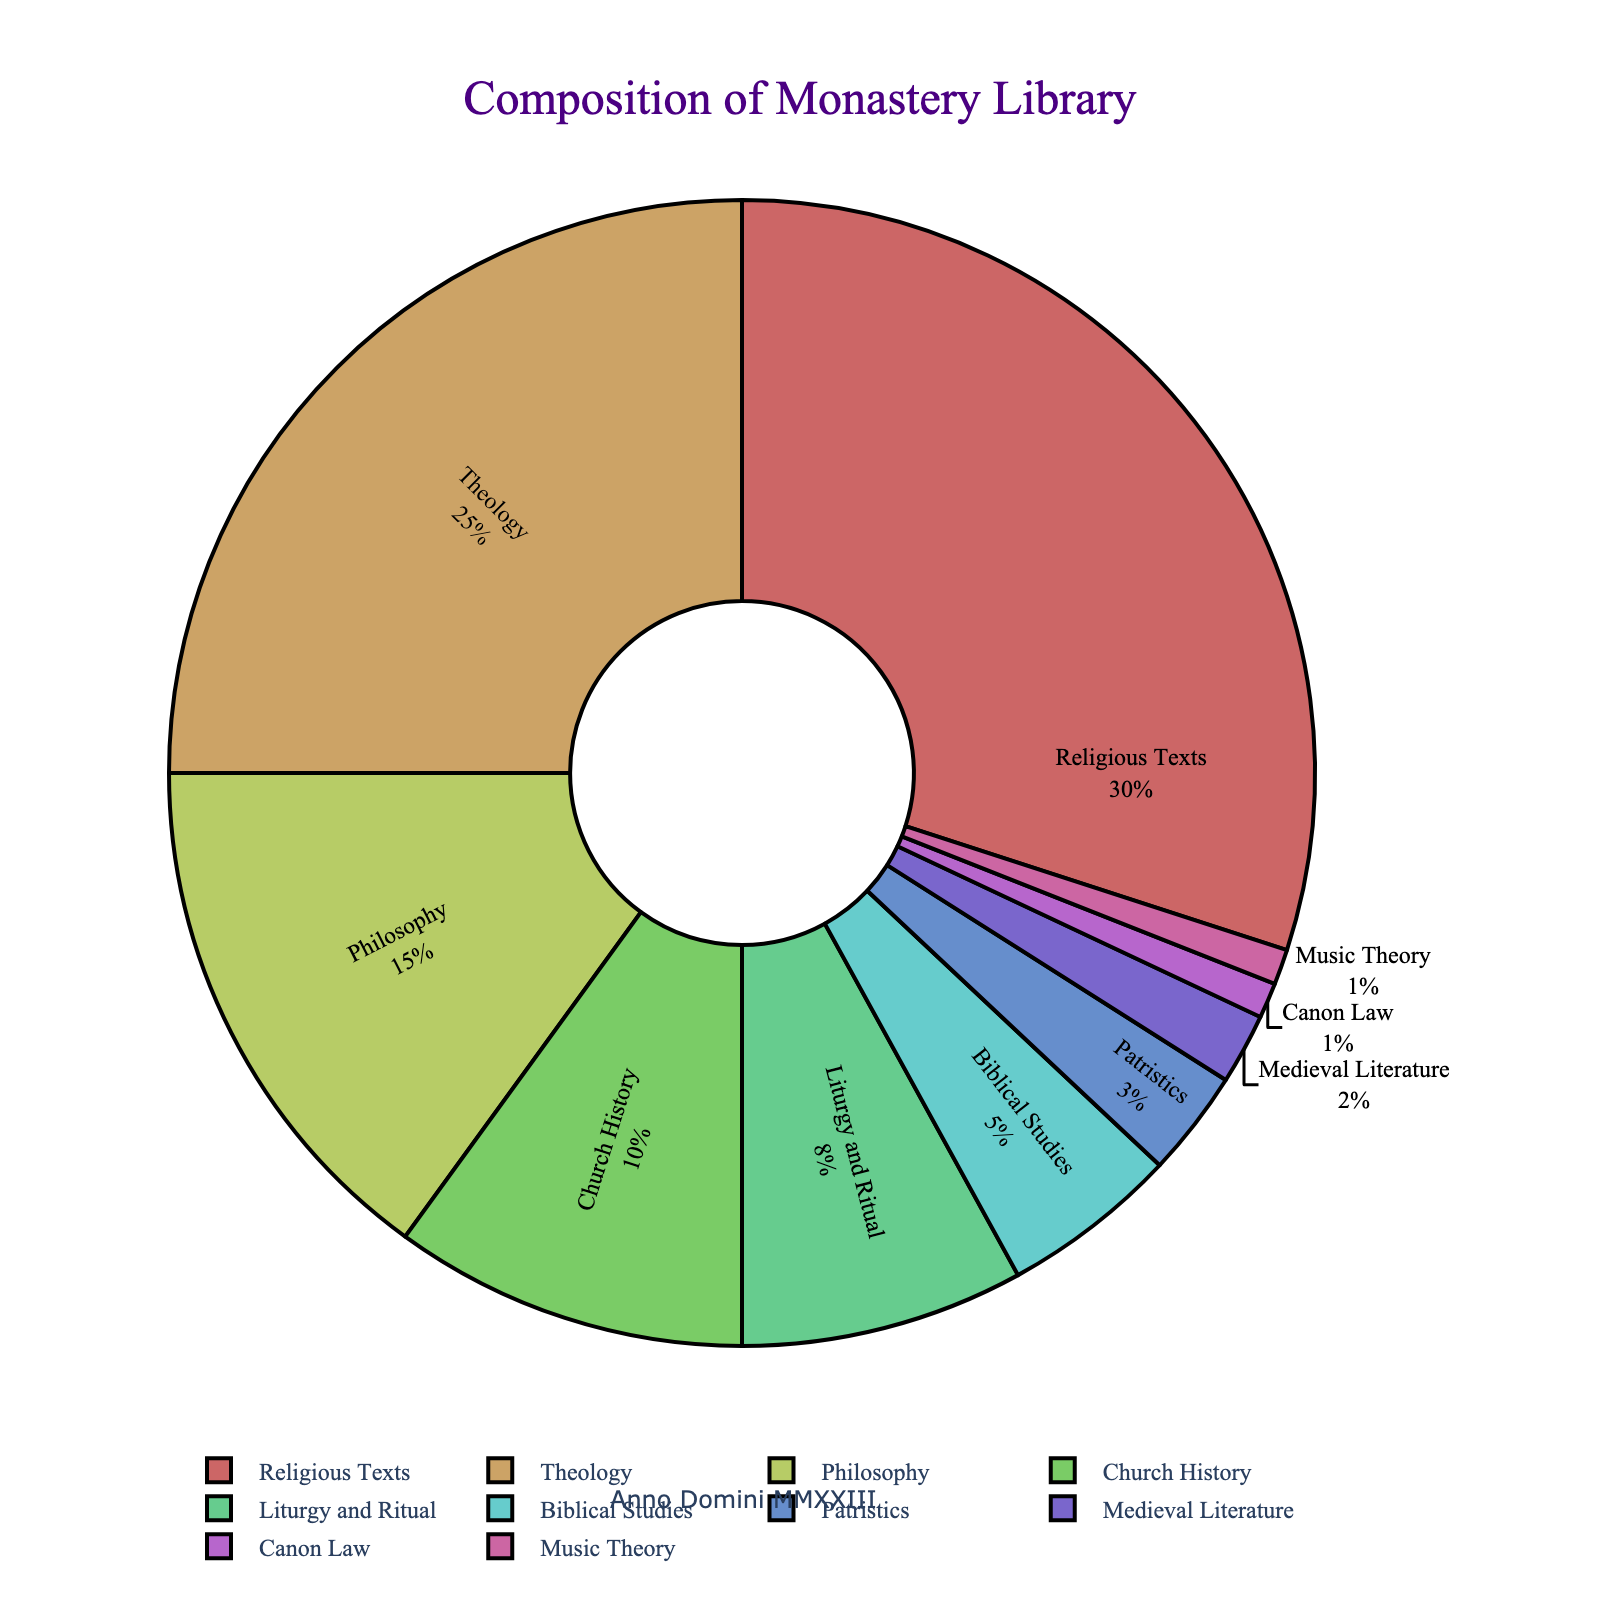What percentage of the monastery library's collection is dedicated to Philosophy? The pie chart indicates that Philosophy accounts for 15% of the library's collection as shown in the labeled sections.
Answer: 15% Which subject occupies a larger portion of the library, Church History or Liturgy and Ritual? Church History is represented by a segment labeled with 10%, whereas Liturgy and Ritual is labeled with 8%, indicating Church History occupies a larger portion.
Answer: Church History What is the combined percentage of the library's collection dedicated to Biblical Studies and Patristics? Biblical Studies occupies 5% of the collection and Patristics occupies 3%. Adding these percentages together results in 5% + 3% = 8%.
Answer: 8% Which subject has the smallest representation in the library's collection and what percentage does it hold? The smallest segment in the pie chart is labeled with Canon Law and Music Theory, each holding 1% of the collection.
Answer: Canon Law and Music Theory, 1% Is the percentage of Theology in the library greater than twice the percentage of Medieval Literature? Theology occupies 25% of the collection, while Medieval Literature occupies 2%. Twice the percentage of Medieval Literature is 2% * 2 = 4%. Since 25% is greater than 4%, the answer is yes.
Answer: Yes What is the difference in percentage between the most represented subject and the least represented subjects combined? The most represented subject is Religious Texts at 30%. The least represented subjects are Canon Law and Music Theory, each at 1%, combined to 2%. The difference is 30% - 2% = 28%.
Answer: 28% In terms of percentage, how much more of the library is dedicated to Religious Texts compared to Biblical Studies? Religious Texts occupy 30% of the library's collection, while Biblical Studies occupy 5%. The difference between these percentages is 30% - 5% = 25%.
Answer: 25% What is the average percentage of the subjects that individually occupy less than 5% of the library's collection? Subjects under 5% are Patristics (3%), Medieval Literature (2%), Canon Law (1%), Music Theory (1%). Average is (3%+2%+1%+1%)/4 = 7%/4 = 1.75%.
Answer: 1.75% Which subject category's segment appears just next to Theology in the pie chart, visually speaking? Since the layout of segments often directly affects adjacent subject categories in pie charts, Philosophy appears next to Theology based on the data's order.
Answer: Philosophy If the library decides to increase its Medieval Literature collection by 3% at the expense of Religious Texts, what would be the new percentages for both subjects? Current percentages: Medieval Literature 2%, Religious Texts 30%. Medieval Literature increases to 2% + 3% = 5%, Religious Texts decreases to 30% - 3% = 27%.
Answer: Medieval Literature 5%, Religious Texts 27% 